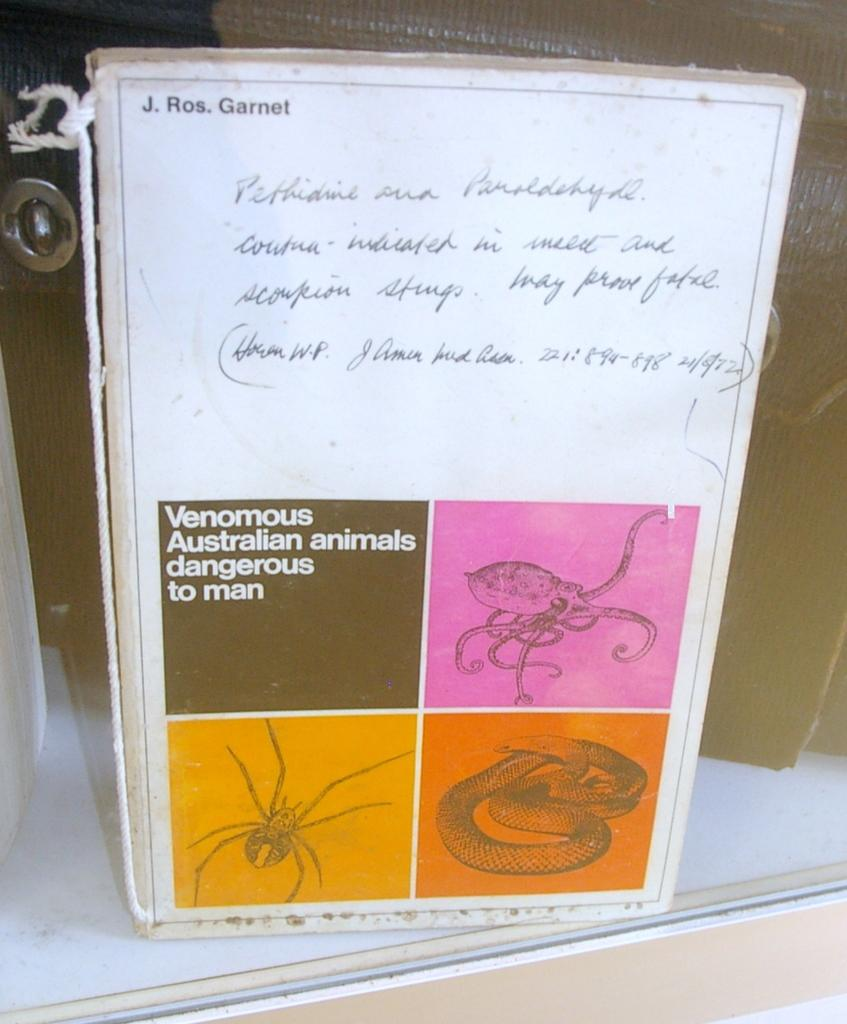What is the main subject of the image? The main subject of the image is a book. What can be seen on the front page of the book? The front page of the book contains a picture of insects and a picture of a snake. How does the book help the doctor sleep better at night? The image does not show a doctor or any information about sleep, so it cannot be determined how the book might affect a doctor's sleep. 